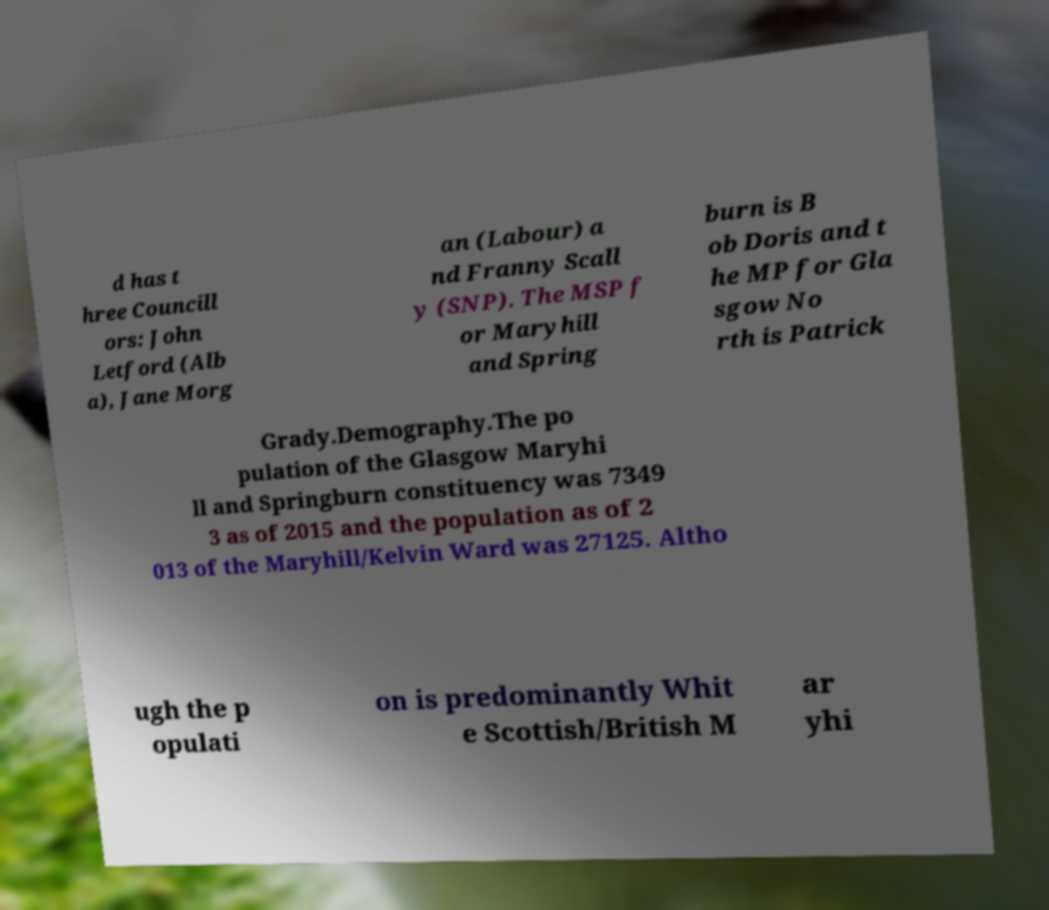Could you extract and type out the text from this image? d has t hree Councill ors: John Letford (Alb a), Jane Morg an (Labour) a nd Franny Scall y (SNP). The MSP f or Maryhill and Spring burn is B ob Doris and t he MP for Gla sgow No rth is Patrick Grady.Demography.The po pulation of the Glasgow Maryhi ll and Springburn constituency was 7349 3 as of 2015 and the population as of 2 013 of the Maryhill/Kelvin Ward was 27125. Altho ugh the p opulati on is predominantly Whit e Scottish/British M ar yhi 